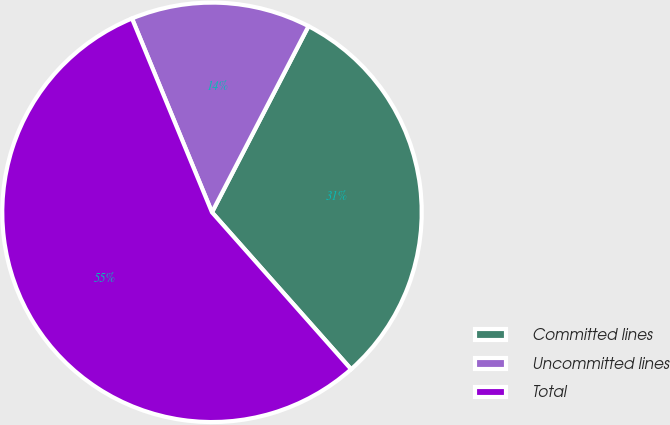<chart> <loc_0><loc_0><loc_500><loc_500><pie_chart><fcel>Committed lines<fcel>Uncommitted lines<fcel>Total<nl><fcel>30.84%<fcel>13.84%<fcel>55.31%<nl></chart> 